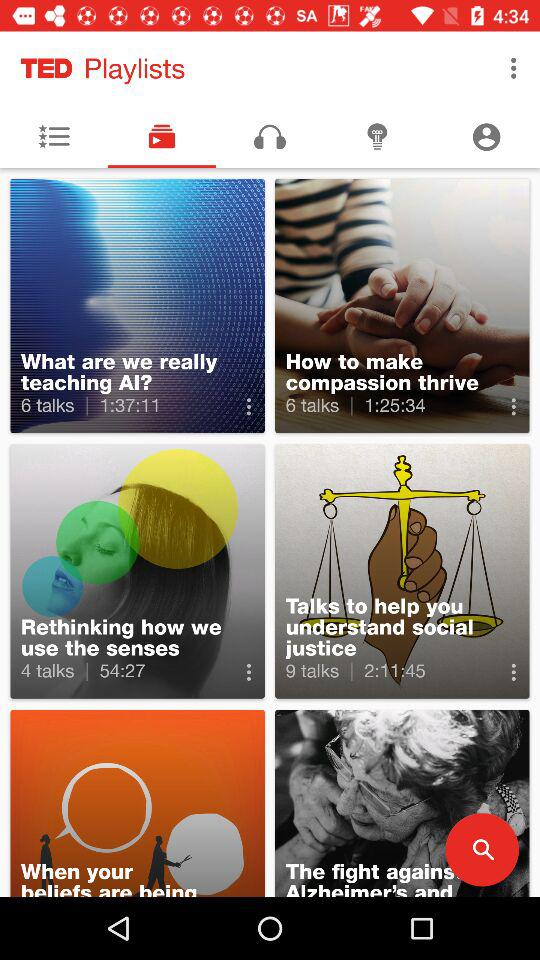How many more talks are there about how to make compassion thrive than about rethinking how we use the senses?
Answer the question using a single word or phrase. 2 